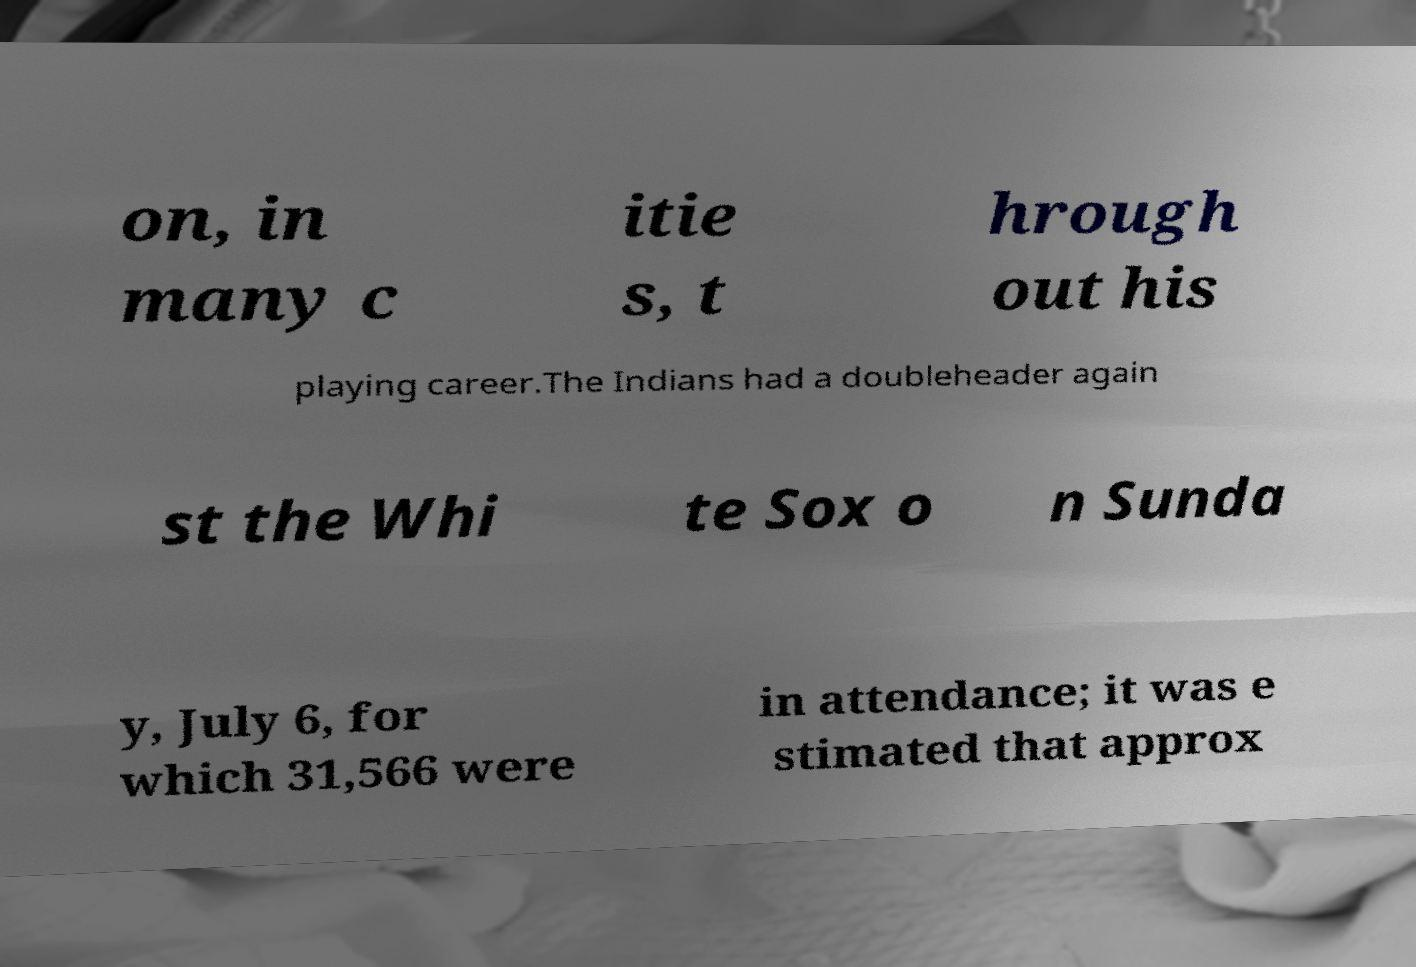There's text embedded in this image that I need extracted. Can you transcribe it verbatim? on, in many c itie s, t hrough out his playing career.The Indians had a doubleheader again st the Whi te Sox o n Sunda y, July 6, for which 31,566 were in attendance; it was e stimated that approx 